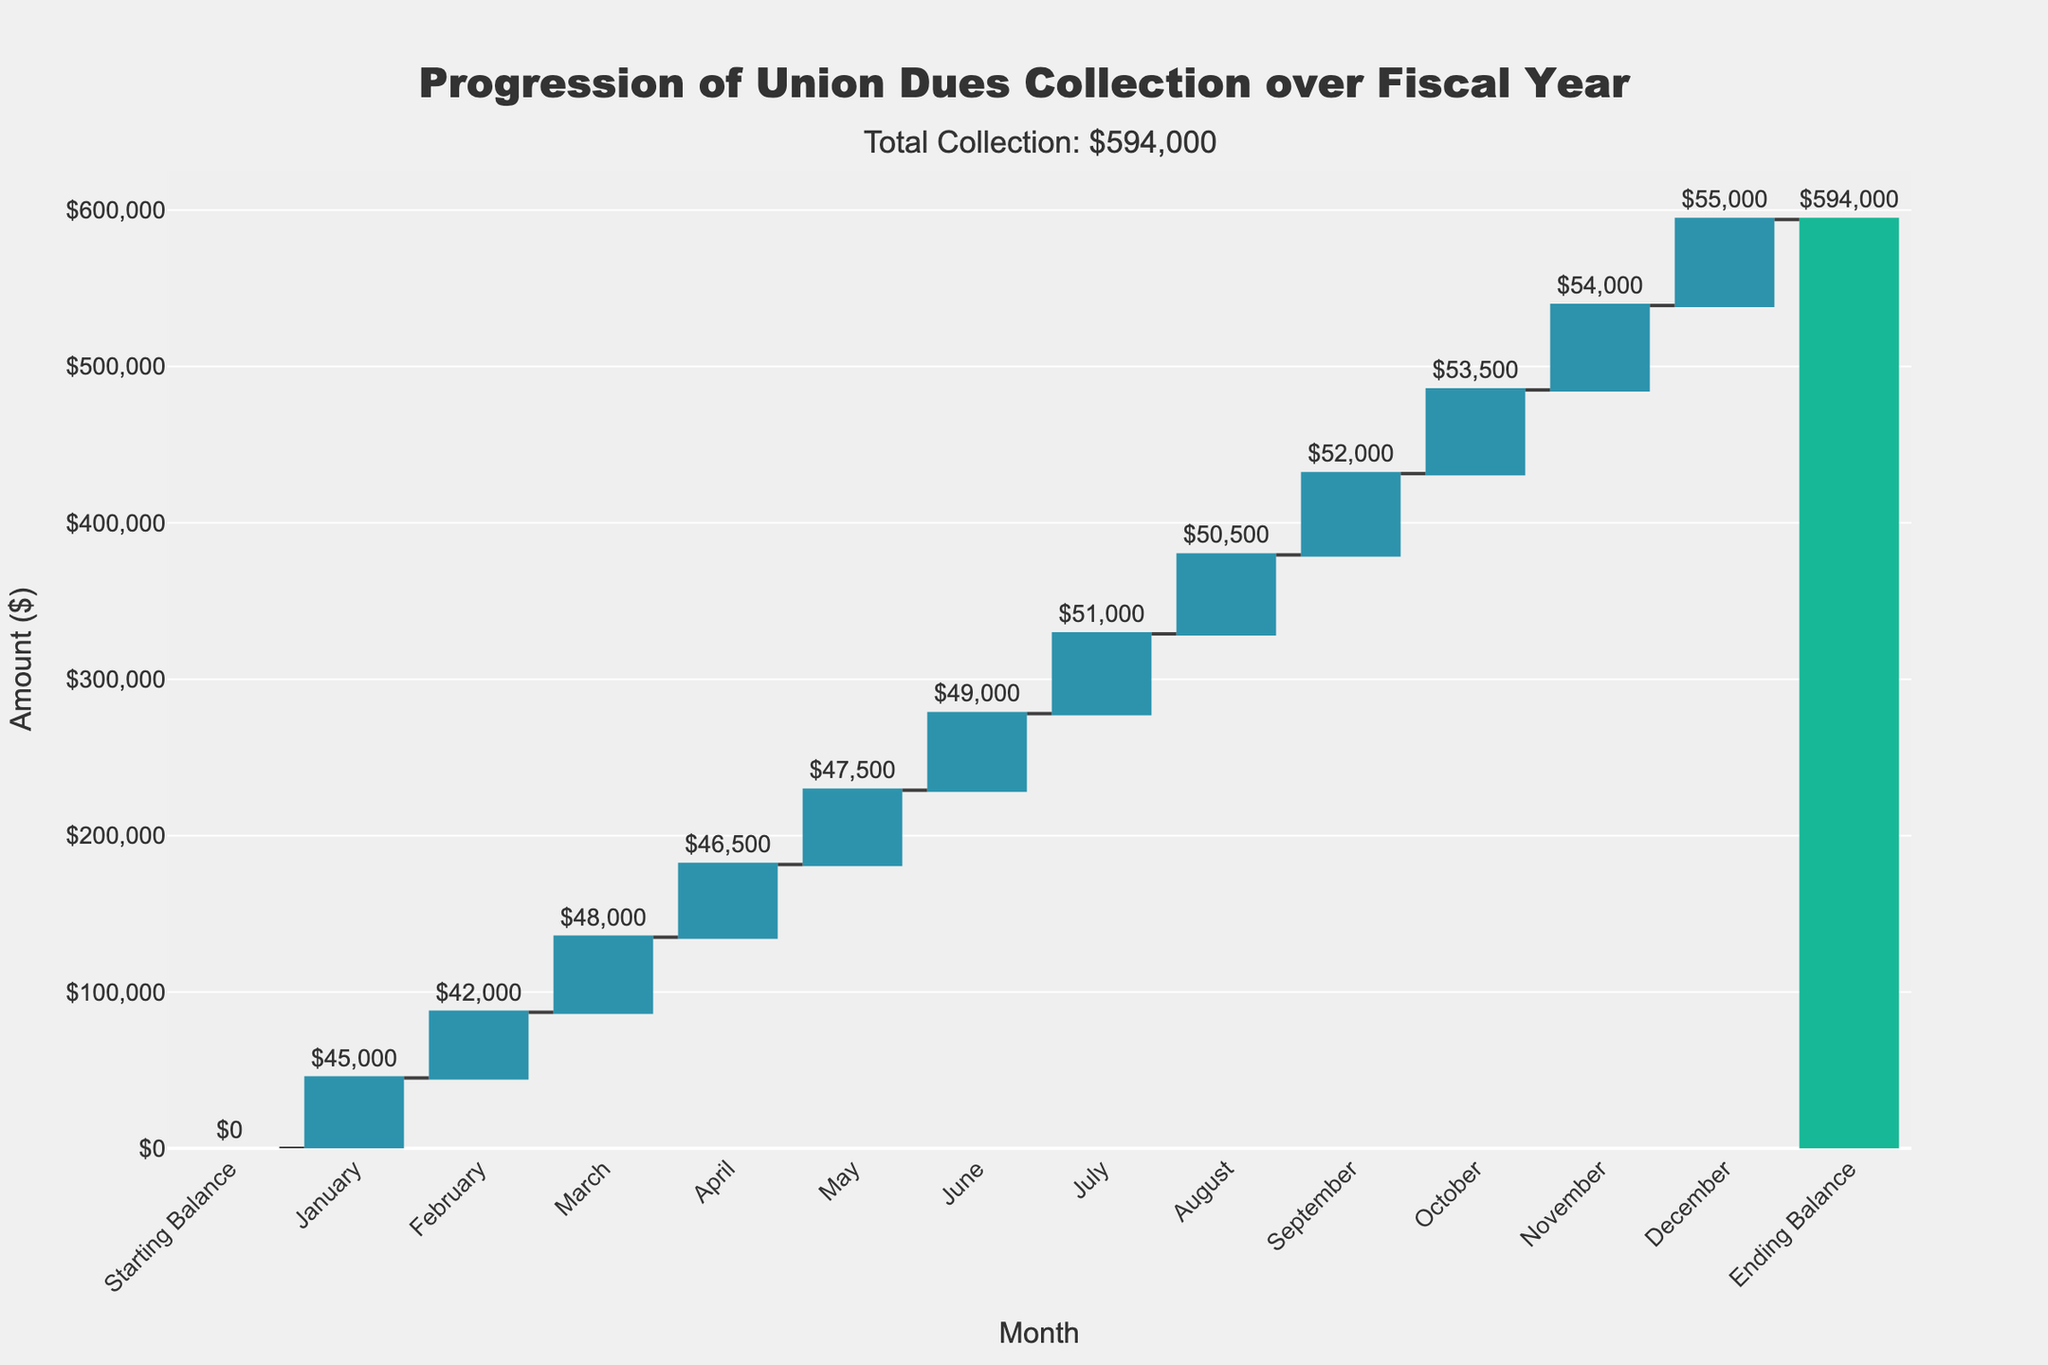What is the title of the figure? The title is usually located at the top of the figure and provides a summary of what the chart is about. In this figure, the title clearly states the chart's purpose.
Answer: Progression of Union Dues Collection over Fiscal Year What is the total collection amount displayed as an annotation? The annotation is a text element added to the figure to provide additional information. In this figure, it shows the total collection amount prominently above the chart.
Answer: $594,000 How much was collected in January? To determine the January collection, look at the first bar after the starting balance, which is labeled "January". The value is displayed either on top of the bar or alongside it.
Answer: $45,000 Which month had the highest collection amount? To find the month with the highest collection amount, compare the heights of the bars representing each month. The tallest bar corresponds to the highest amount collected in that month.
Answer: December Which months had a decrease in collections compared to the previous month? A decrease is indicated by a red bar in a waterfall chart. Identifying these months involves observing which bars are red.
Answer: February and August What is the cumulative amount collected by the end of June? Calculate the cumulative amount by summing the values from January to June. This involves adding the amounts collected each month up to June. The cumulative sum is $45,000 + $42,000 + $48,000 + $46,500 + $47,500 + $49,000.
Answer: $278,000 What is the difference in collection amount between the highest and lowest months? First, identify the highest and lowest monthly collections, which are $55,000 in December and $42,000 in February. Then, subtract the smaller value from the larger value to find the difference.
Answer: $13,000 How does the collection in November compare to March? To compare, look at the values of the bars for March and November. The value for March is $48,000, and the value for November is $54,000. Compare these two amounts.
Answer: November is $6,000 higher than March What is the average monthly collection amount from January to December? To find the average, sum the values from January to December and then divide by the number of months (12). The sum is $45,000+ $42,000 + $48,000 + $46,500 + $47,500 + $49,000 + $51,000 + $50,500 + $52,000 + $53,500 + $54,000 + $55,000.
Answer: $49,750 What is the color coding for increasing and decreasing collections? The color coding for increasing and decreasing collections is indicated by different colors on the bars. Typically, increasing values are in one color, and decreasing values are in another. The chart shows increasing collections in greenish-blue and decreasing collections in red.
Answer: Greenish-blue for increasing, red for decreasing 